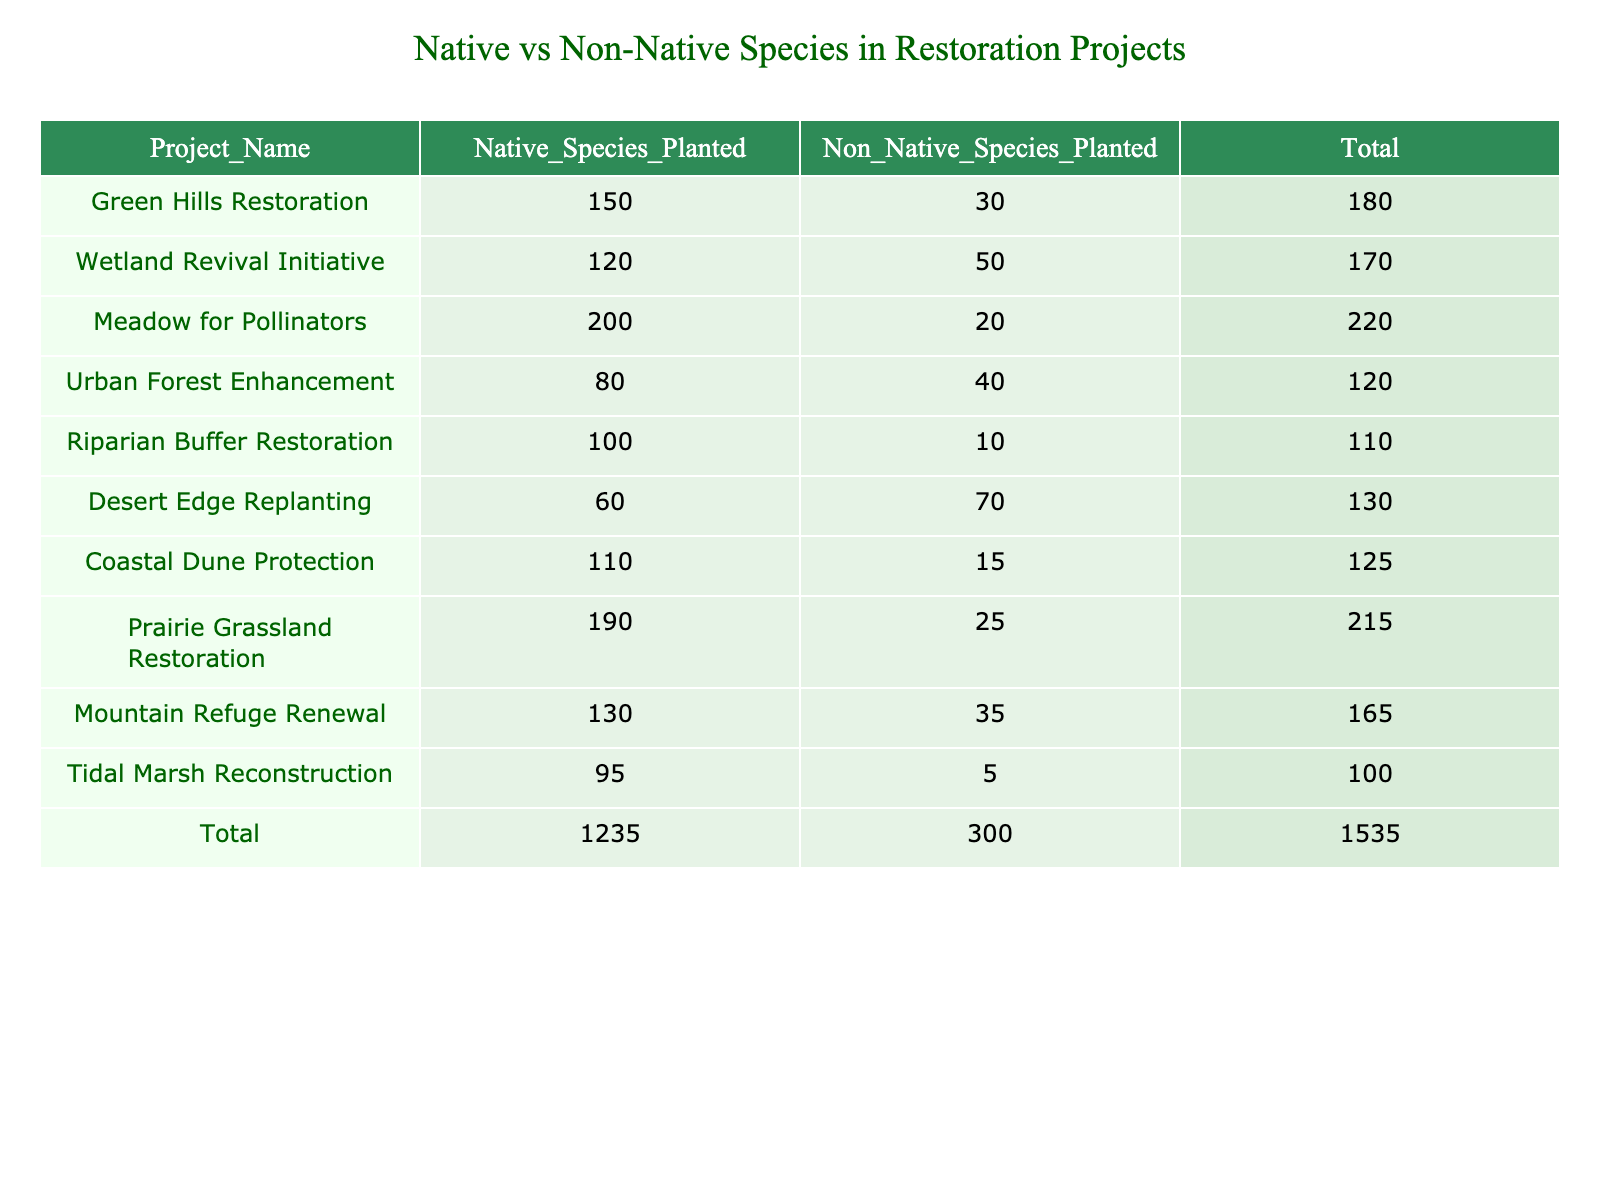What is the total number of native species planted across all projects? To find the total number of native species planted, sum the values in the "Native_Species_Planted" column. The values are 150, 120, 200, 80, 100, 60, 110, 190, 130, and 95. Adding these together: 150 + 120 + 200 + 80 + 100 + 60 + 110 + 190 + 130 + 95 = 1,235.
Answer: 1,235 Which project planted the highest number of non-native species? To identify the project that planted the highest number of non-native species, compare the values in the "Non_Native_Species_Planted" column. The maximum value is 70 from the "Desert Edge Replanting" project.
Answer: Desert Edge Replanting Is it true that the 'Meadow for Pollinators' project has more native species than the 'Urban Forest Enhancement' project? To verify this, compare the values for native species planted in both projects. 'Meadow for Pollinators' planted 200 native species, while 'Urban Forest Enhancement' planted 80. Since 200 is greater than 80, the statement is true.
Answer: Yes What is the average number of non-native species planted across all projects? First, identify the sum of non-native species across all projects: 30 + 50 + 20 + 40 + 10 + 70 + 15 + 25 + 35 + 5 = 300. There are 10 projects, so the average is calculated by dividing the total by the number of projects: 300 / 10 = 30.
Answer: 30 How many more native species were planted in the 'Prairie Grassland Restoration' project compared to the 'Coastal Dune Protection' project? First, find the native species planted in both projects: 'Prairie Grassland Restoration' has 190 native species and 'Coastal Dune Protection' has 110 native species. Now, calculate the difference: 190 - 110 = 80.
Answer: 80 Which project has the lowest total number of species planted? To find this, first calculate the total species for each project by adding native and non-native species for each case. The totals are: 180, 170, 220, 120, 110, 130, 125, 215, 165, and 100. The lowest total is 100 from the 'Tidal Marsh Reconstruction' project.
Answer: Tidal Marsh Reconstruction Are there more projects that have planted native species above 100 than below? Count the projects with native species above and below 100. The projects above 100 are: Green Hills Restoration, Wetland Revival Initiative, Meadow for Pollinators, Riparian Buffer Restoration, Coastal Dune Protection, Prairie Grassland Restoration, Tidal Marsh Reconstruction (7). Below 100 are: Urban Forest Enhancement, Desert Edge Replanting (2). Therefore, there are more projects above 100.
Answer: Yes What percentage of the total species planted are native species? First, calculate the total number of species planted, which is 1,235 native and 300 non-native, giving a grand total of 1,535. Next, calculate the percentage of native species: (1,235 / 1,535) * 100 = 80.5%.
Answer: 80.5% How does the number of non-native species in 'Desert Edge Replanting' compare to the average of non-native species across all projects? The 'Desert Edge Replanting' project has 70 non-native species. The average, as calculated earlier, is 30. Compare the two values: 70 is greater than 30.
Answer: Greater than average 